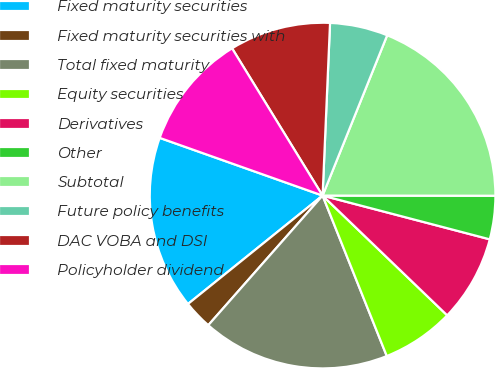Convert chart. <chart><loc_0><loc_0><loc_500><loc_500><pie_chart><fcel>Fixed maturity securities<fcel>Fixed maturity securities with<fcel>Total fixed maturity<fcel>Equity securities<fcel>Derivatives<fcel>Other<fcel>Subtotal<fcel>Future policy benefits<fcel>DAC VOBA and DSI<fcel>Policyholder dividend<nl><fcel>16.21%<fcel>2.71%<fcel>17.56%<fcel>6.76%<fcel>8.11%<fcel>4.06%<fcel>18.92%<fcel>5.41%<fcel>9.46%<fcel>10.81%<nl></chart> 